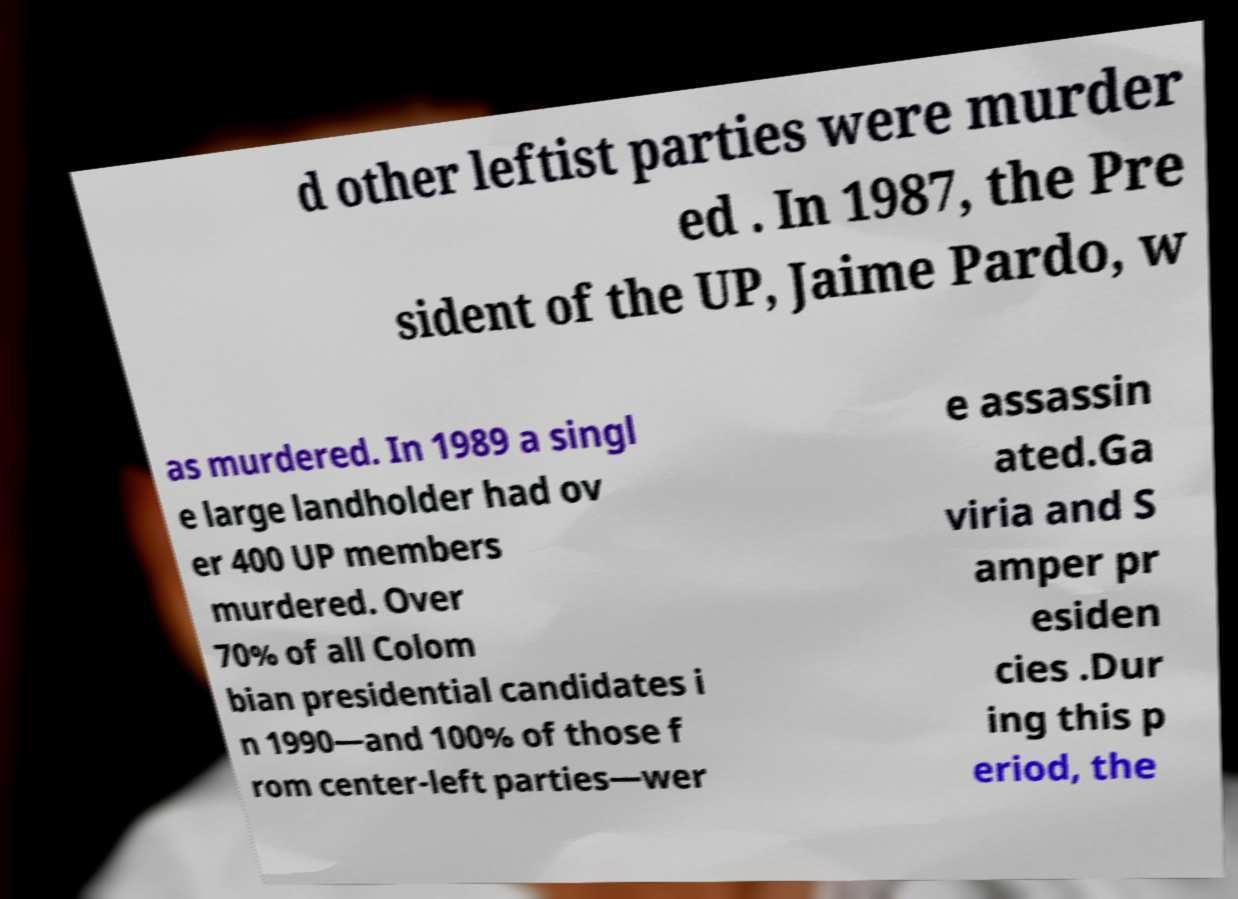For documentation purposes, I need the text within this image transcribed. Could you provide that? d other leftist parties were murder ed . In 1987, the Pre sident of the UP, Jaime Pardo, w as murdered. In 1989 a singl e large landholder had ov er 400 UP members murdered. Over 70% of all Colom bian presidential candidates i n 1990—and 100% of those f rom center-left parties—wer e assassin ated.Ga viria and S amper pr esiden cies .Dur ing this p eriod, the 